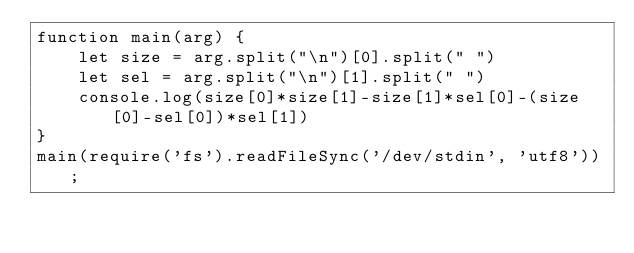Convert code to text. <code><loc_0><loc_0><loc_500><loc_500><_JavaScript_>function main(arg) {
    let size = arg.split("\n")[0].split(" ")
    let sel = arg.split("\n")[1].split(" ")
    console.log(size[0]*size[1]-size[1]*sel[0]-(size[0]-sel[0])*sel[1])
}
main(require('fs').readFileSync('/dev/stdin', 'utf8'));</code> 